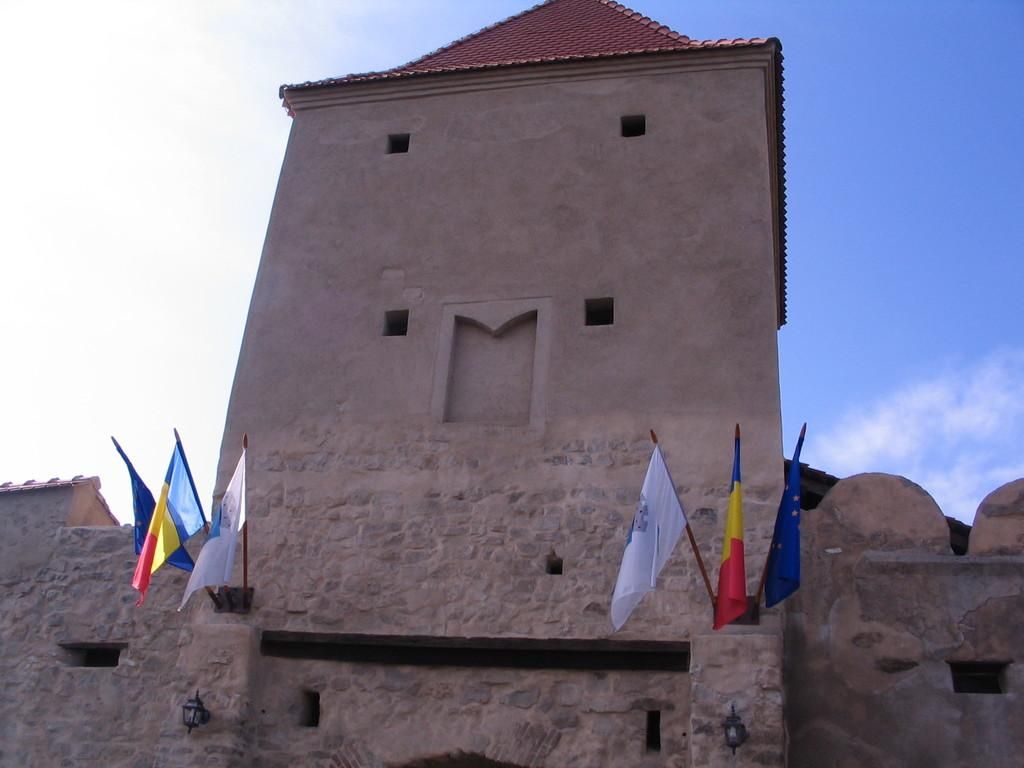What is the color of the building in the image? The building in the image is brown-colored. What is located in front of the building? There are flags in front of the building. What colors are present on the flags? The flags have white, red, yellow, and blue colors. What can be seen in the background of the image? The sky is visible in the background of the image. What colors are present in the sky? The sky has white and blue colors. Where are the ducks located in the image? There are no ducks present in the image. What type of produce is being sold in front of the building? There is no produce being sold in front of the building; only flags are present. 